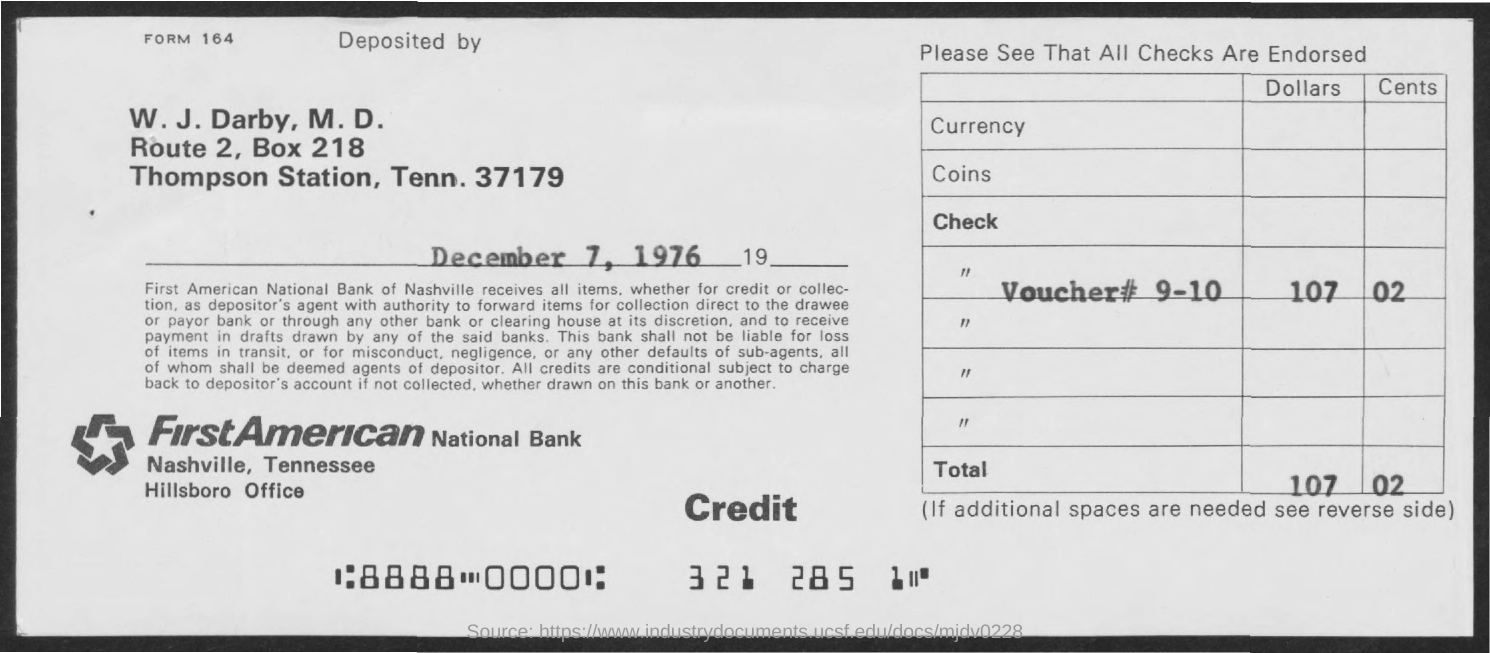What is the date on the document?
Offer a terse response. December 7, 1976. What is the Total?
Provide a short and direct response. 107 02. 